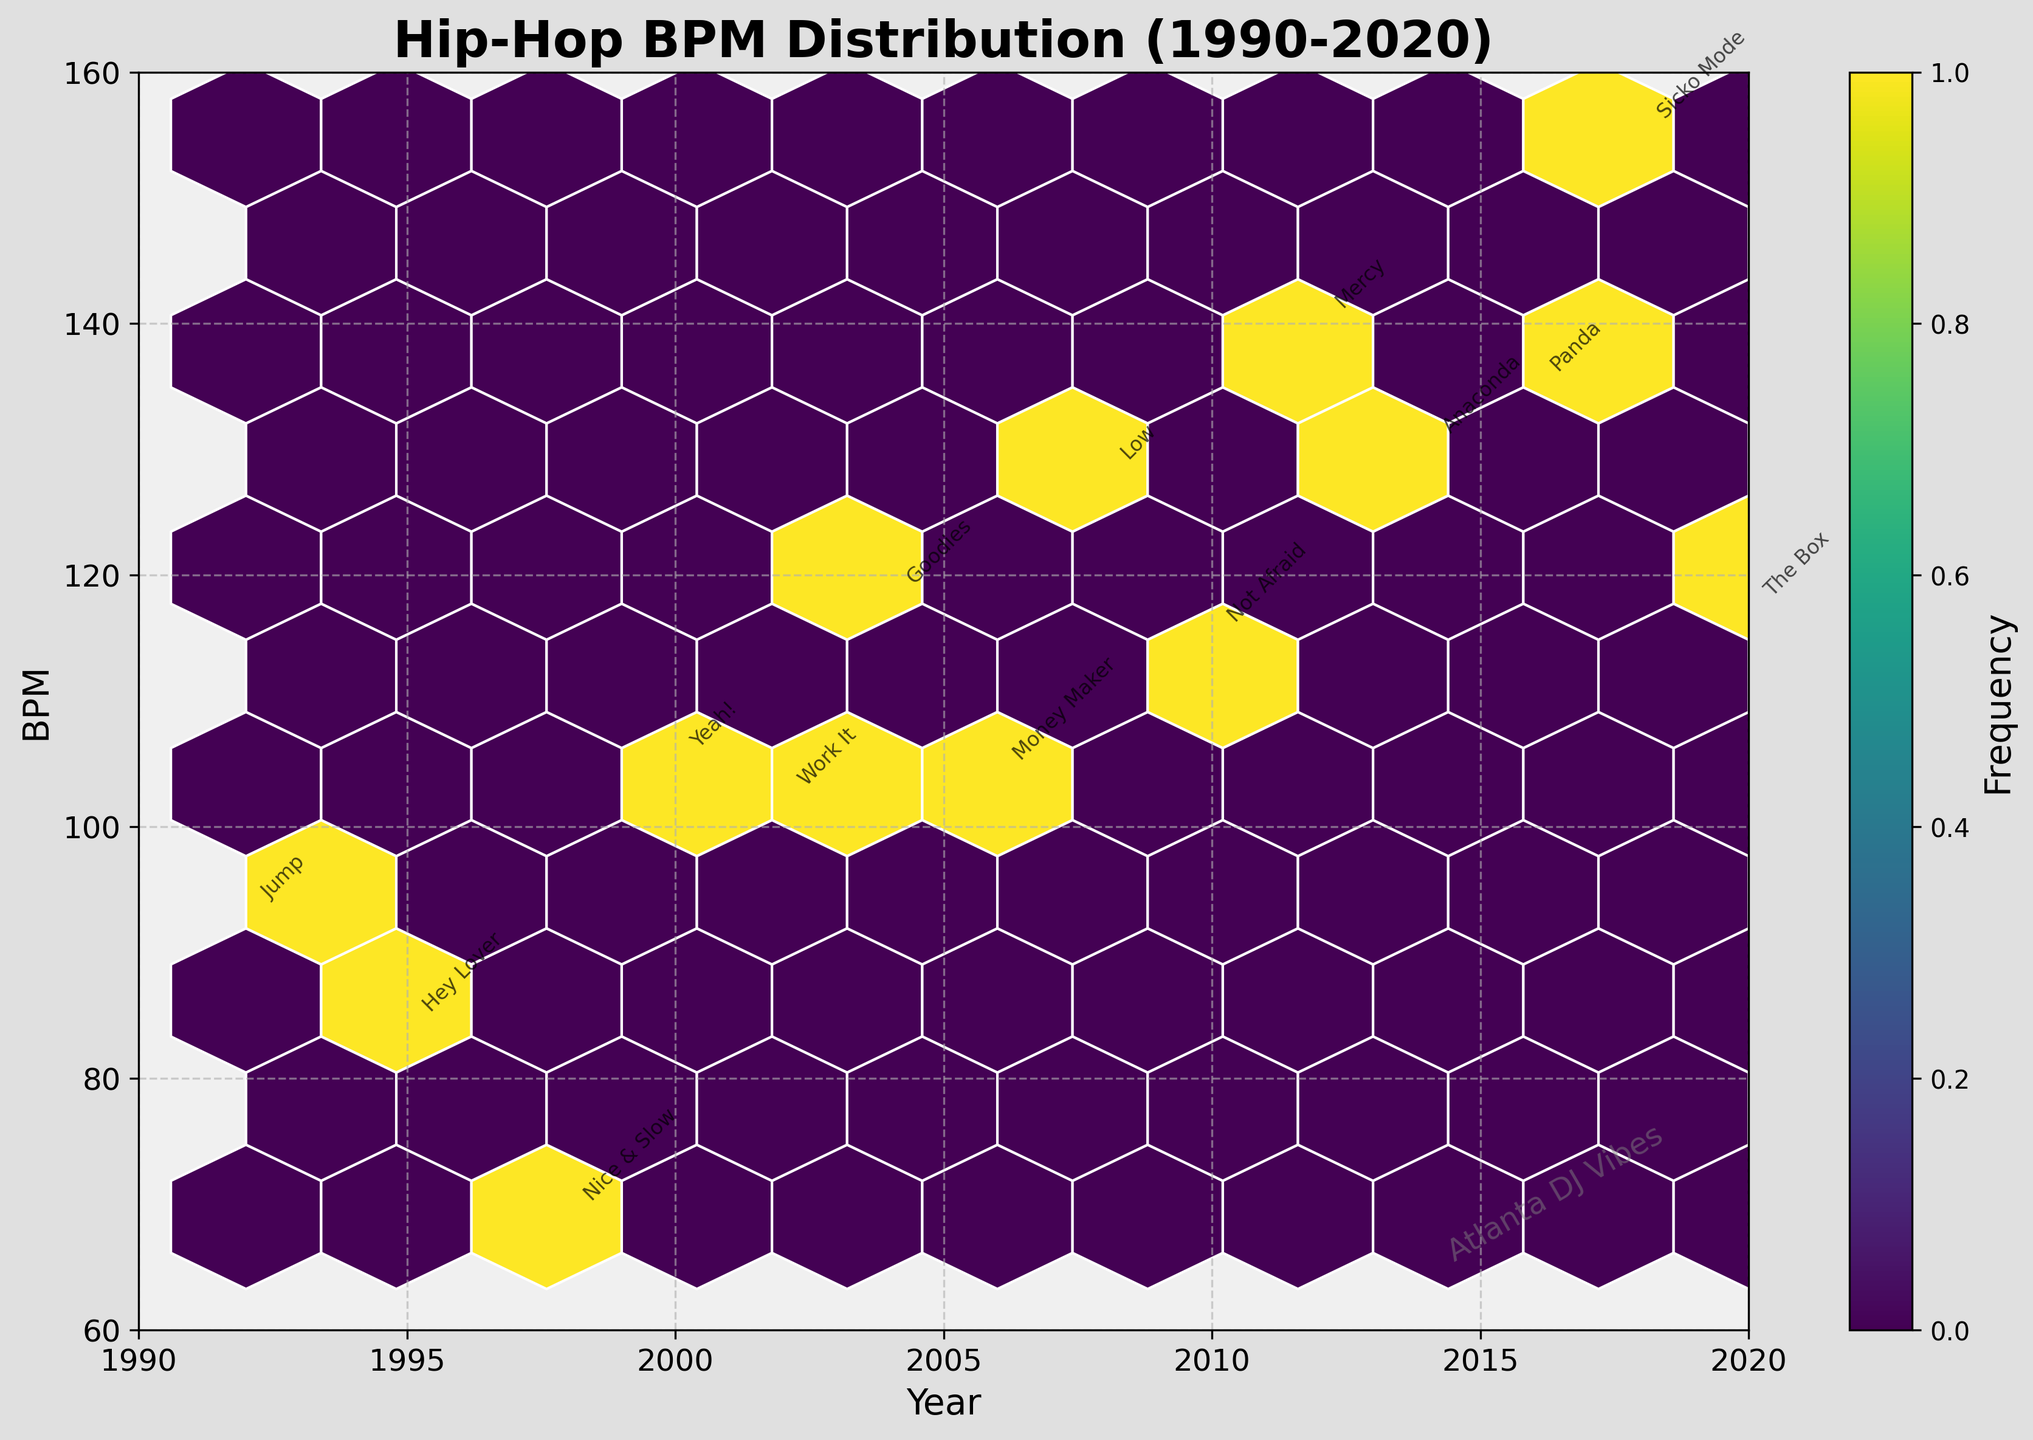How many data points are visualized in the hexbin plot? By counting the annotations for each data point in the figure, there are 14 unique tracks mentioned.
Answer: 14 What is the BPM range where the tracks are most densely concentrated? By observing the color intensity in the hexbin plot, the densest concentration appears to be around the 115-140 BPM range from 2008 to 2020, where the color is the darkest.
Answer: 115-140 BPM Which year has the highest BPM track, and what is its BPM? Looking at the annotations, the track "Sicko Mode" by Travis Scott in 2018 has the highest BPM of 155.
Answer: 2018, 155 BPM How many tracks have a BPM greater than 120? By checking the annotations and their positions, we see four tracks: "Low" by Flo Rida, "Anaconda" by Nicki Minaj, "Panda" by Desiigner, and "Sicko Mode" by Travis Scott.
Answer: 4 What is the average BPM of the tracks released in the 1990s? The tracks from the 1990s are: "Jump" (93 BPM), "Hey Lover" (84 BPM), and "Nice & Slow" (69 BPM). The average is calculated as (93 + 84 + 69) / 3 = 82.
Answer: 82 BPM Which track has the lowest BPM, and what is its BPM? By checking the annotations for BPM values, "Nice & Slow" by Usher in 1998 has the lowest BPM of 69.
Answer: "Nice & Slow," 69 BPM Is the BPM trend increasing or decreasing over the years? By observing the BPM values from each year, it can be seen that the BPM generally increases over the years, with notable high BPM tracks in recent years (Sicko Mode, Panda).
Answer: Increasing What is the BPM of the track released in 2004? Based on the annotations, the track "Goodies" by Ciara in 2004 has a BPM of 118.
Answer: 118 BPM 